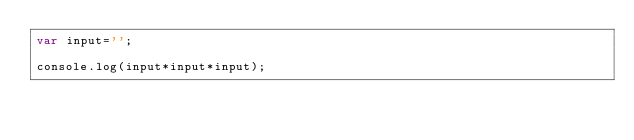<code> <loc_0><loc_0><loc_500><loc_500><_JavaScript_>var input='';

console.log(input*input*input);</code> 